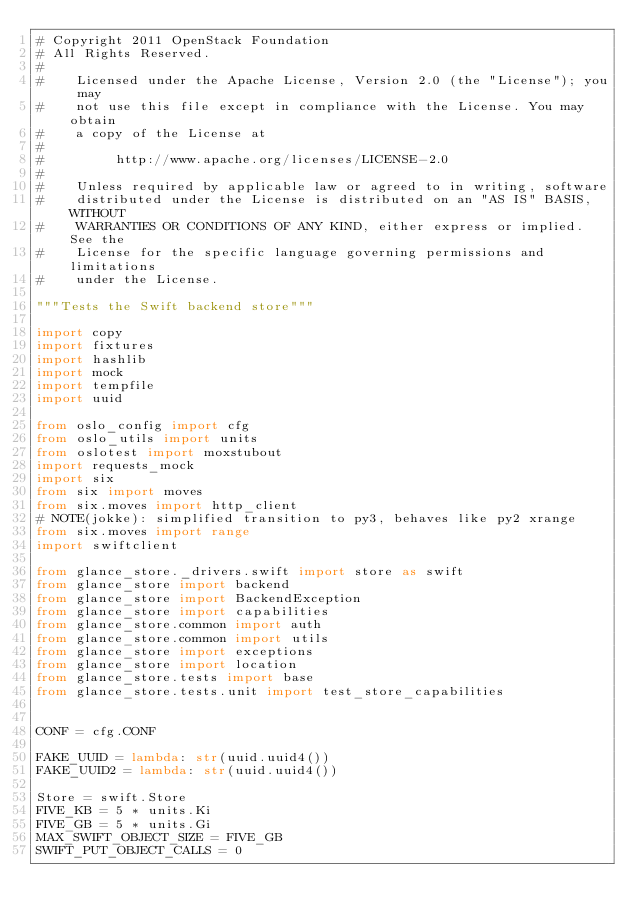Convert code to text. <code><loc_0><loc_0><loc_500><loc_500><_Python_># Copyright 2011 OpenStack Foundation
# All Rights Reserved.
#
#    Licensed under the Apache License, Version 2.0 (the "License"); you may
#    not use this file except in compliance with the License. You may obtain
#    a copy of the License at
#
#         http://www.apache.org/licenses/LICENSE-2.0
#
#    Unless required by applicable law or agreed to in writing, software
#    distributed under the License is distributed on an "AS IS" BASIS, WITHOUT
#    WARRANTIES OR CONDITIONS OF ANY KIND, either express or implied. See the
#    License for the specific language governing permissions and limitations
#    under the License.

"""Tests the Swift backend store"""

import copy
import fixtures
import hashlib
import mock
import tempfile
import uuid

from oslo_config import cfg
from oslo_utils import units
from oslotest import moxstubout
import requests_mock
import six
from six import moves
from six.moves import http_client
# NOTE(jokke): simplified transition to py3, behaves like py2 xrange
from six.moves import range
import swiftclient

from glance_store._drivers.swift import store as swift
from glance_store import backend
from glance_store import BackendException
from glance_store import capabilities
from glance_store.common import auth
from glance_store.common import utils
from glance_store import exceptions
from glance_store import location
from glance_store.tests import base
from glance_store.tests.unit import test_store_capabilities


CONF = cfg.CONF

FAKE_UUID = lambda: str(uuid.uuid4())
FAKE_UUID2 = lambda: str(uuid.uuid4())

Store = swift.Store
FIVE_KB = 5 * units.Ki
FIVE_GB = 5 * units.Gi
MAX_SWIFT_OBJECT_SIZE = FIVE_GB
SWIFT_PUT_OBJECT_CALLS = 0</code> 